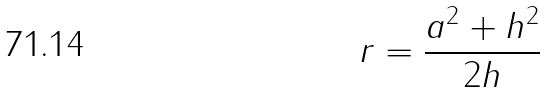Convert formula to latex. <formula><loc_0><loc_0><loc_500><loc_500>r = \frac { a ^ { 2 } + h ^ { 2 } } { 2 h }</formula> 